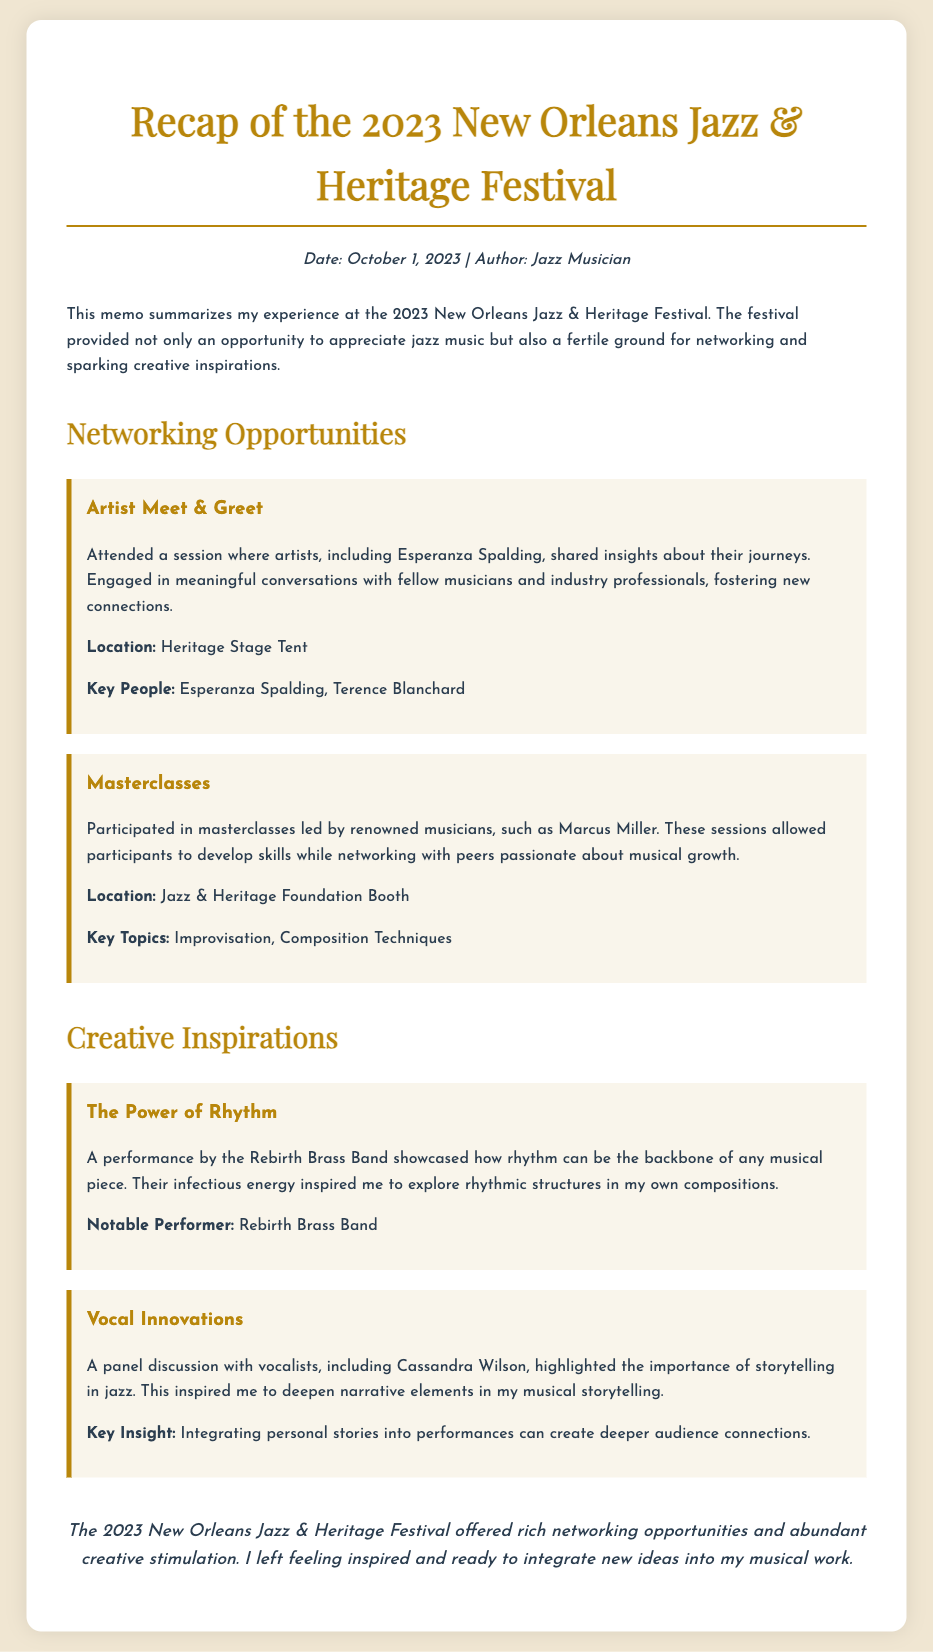what is the date of the festival? The date mentioned for the festival is October 1, 2023.
Answer: October 1, 2023 who shared insights during the Artist Meet & Greet? Esperanza Spalding is noted as one of the artists who shared insights during the session.
Answer: Esperanza Spalding what was a key topic in the Masterclasses? One of the key topics in the Masterclasses was Improvisation.
Answer: Improvisation who performed and inspired exploration of rhythmic structures? The Rebirth Brass Band performed and inspired the exploration of rhythmic structures.
Answer: Rebirth Brass Band what type of event was held at the Heritage Stage Tent? The event held at the Heritage Stage Tent was the Artist Meet & Greet.
Answer: Artist Meet & Greet what is a key insight from the panel discussion with vocalists? A key insight is that integrating personal stories into performances can create deeper audience connections.
Answer: Integrating personal stories how did the festival affect the author's feelings about their music? The author felt inspired and ready to integrate new ideas into their musical work after the festival.
Answer: Inspired where was the Jazz & Heritage Foundation Booth located? The Jazz & Heritage Foundation Booth is mentioned as the location for the Masterclasses.
Answer: Jazz & Heritage Foundation Booth what are two notable musicians mentioned in the document? Two notable musicians mentioned are Esperanza Spalding and Marcus Miller.
Answer: Esperanza Spalding, Marcus Miller 